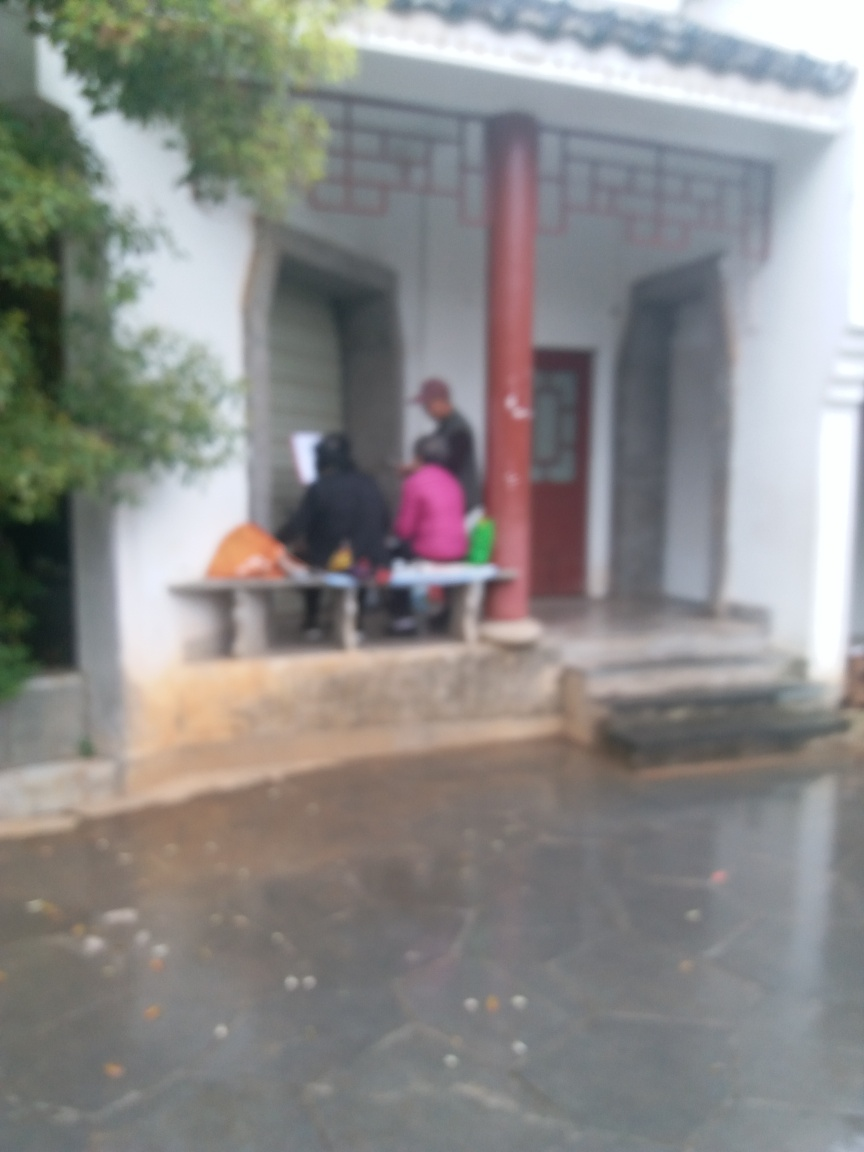What is present in the image?
A. Noise
B. Sharpness
C. Texture details
D. Brightness The image is not clear, and the attributes cannot be accurately assessed. However, we can infer that 'A. Noise' is the most prevalent characteristic given the visible blur and lack of definition, preventing us from seeing sharpness, texture details, or true brightness levels. 